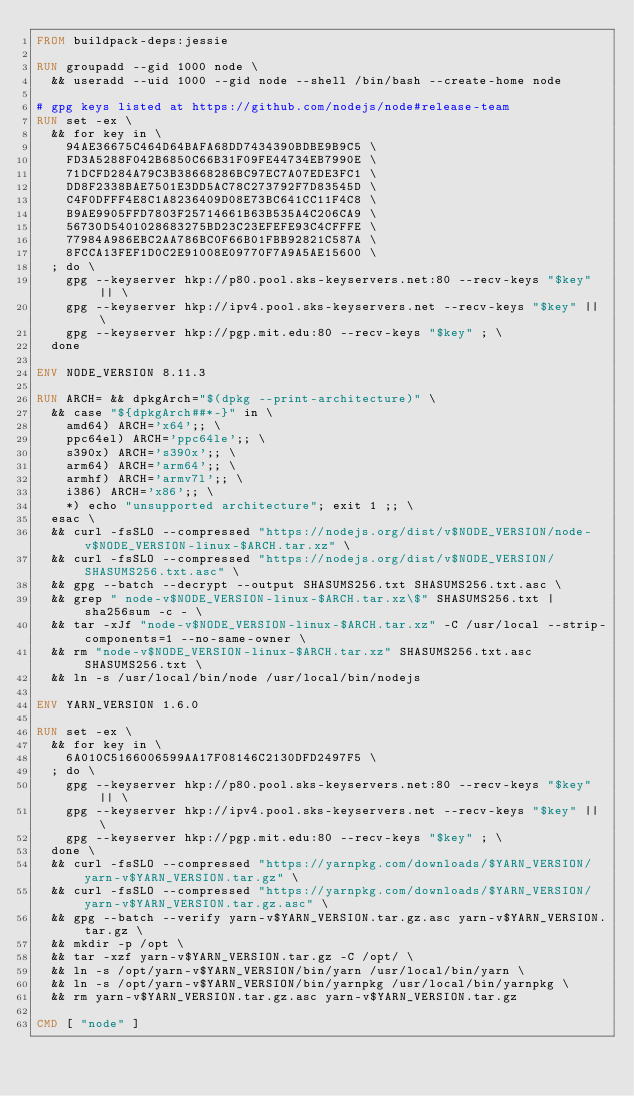<code> <loc_0><loc_0><loc_500><loc_500><_Dockerfile_>FROM buildpack-deps:jessie

RUN groupadd --gid 1000 node \
  && useradd --uid 1000 --gid node --shell /bin/bash --create-home node

# gpg keys listed at https://github.com/nodejs/node#release-team
RUN set -ex \
  && for key in \
    94AE36675C464D64BAFA68DD7434390BDBE9B9C5 \
    FD3A5288F042B6850C66B31F09FE44734EB7990E \
    71DCFD284A79C3B38668286BC97EC7A07EDE3FC1 \
    DD8F2338BAE7501E3DD5AC78C273792F7D83545D \
    C4F0DFFF4E8C1A8236409D08E73BC641CC11F4C8 \
    B9AE9905FFD7803F25714661B63B535A4C206CA9 \
    56730D5401028683275BD23C23EFEFE93C4CFFFE \
    77984A986EBC2AA786BC0F66B01FBB92821C587A \
    8FCCA13FEF1D0C2E91008E09770F7A9A5AE15600 \
  ; do \
    gpg --keyserver hkp://p80.pool.sks-keyservers.net:80 --recv-keys "$key" || \
    gpg --keyserver hkp://ipv4.pool.sks-keyservers.net --recv-keys "$key" || \
    gpg --keyserver hkp://pgp.mit.edu:80 --recv-keys "$key" ; \
  done

ENV NODE_VERSION 8.11.3

RUN ARCH= && dpkgArch="$(dpkg --print-architecture)" \
  && case "${dpkgArch##*-}" in \
    amd64) ARCH='x64';; \
    ppc64el) ARCH='ppc64le';; \
    s390x) ARCH='s390x';; \
    arm64) ARCH='arm64';; \
    armhf) ARCH='armv7l';; \
    i386) ARCH='x86';; \
    *) echo "unsupported architecture"; exit 1 ;; \
  esac \
  && curl -fsSLO --compressed "https://nodejs.org/dist/v$NODE_VERSION/node-v$NODE_VERSION-linux-$ARCH.tar.xz" \
  && curl -fsSLO --compressed "https://nodejs.org/dist/v$NODE_VERSION/SHASUMS256.txt.asc" \
  && gpg --batch --decrypt --output SHASUMS256.txt SHASUMS256.txt.asc \
  && grep " node-v$NODE_VERSION-linux-$ARCH.tar.xz\$" SHASUMS256.txt | sha256sum -c - \
  && tar -xJf "node-v$NODE_VERSION-linux-$ARCH.tar.xz" -C /usr/local --strip-components=1 --no-same-owner \
  && rm "node-v$NODE_VERSION-linux-$ARCH.tar.xz" SHASUMS256.txt.asc SHASUMS256.txt \
  && ln -s /usr/local/bin/node /usr/local/bin/nodejs

ENV YARN_VERSION 1.6.0

RUN set -ex \
  && for key in \
    6A010C5166006599AA17F08146C2130DFD2497F5 \
  ; do \
    gpg --keyserver hkp://p80.pool.sks-keyservers.net:80 --recv-keys "$key" || \
    gpg --keyserver hkp://ipv4.pool.sks-keyservers.net --recv-keys "$key" || \
    gpg --keyserver hkp://pgp.mit.edu:80 --recv-keys "$key" ; \
  done \
  && curl -fsSLO --compressed "https://yarnpkg.com/downloads/$YARN_VERSION/yarn-v$YARN_VERSION.tar.gz" \
  && curl -fsSLO --compressed "https://yarnpkg.com/downloads/$YARN_VERSION/yarn-v$YARN_VERSION.tar.gz.asc" \
  && gpg --batch --verify yarn-v$YARN_VERSION.tar.gz.asc yarn-v$YARN_VERSION.tar.gz \
  && mkdir -p /opt \
  && tar -xzf yarn-v$YARN_VERSION.tar.gz -C /opt/ \
  && ln -s /opt/yarn-v$YARN_VERSION/bin/yarn /usr/local/bin/yarn \
  && ln -s /opt/yarn-v$YARN_VERSION/bin/yarnpkg /usr/local/bin/yarnpkg \
  && rm yarn-v$YARN_VERSION.tar.gz.asc yarn-v$YARN_VERSION.tar.gz

CMD [ "node" ]
</code> 